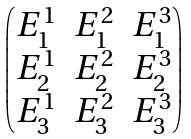Convert formula to latex. <formula><loc_0><loc_0><loc_500><loc_500>\begin{pmatrix} E ^ { 1 } _ { 1 } & E _ { 1 } ^ { 2 } & E _ { 1 } ^ { 3 } \\ E _ { 2 } ^ { 1 } & E _ { 2 } ^ { 2 } & E _ { 2 } ^ { 3 } \\ E _ { 3 } ^ { 1 } & E _ { 3 } ^ { 2 } & E _ { 3 } ^ { 3 } \end{pmatrix}</formula> 